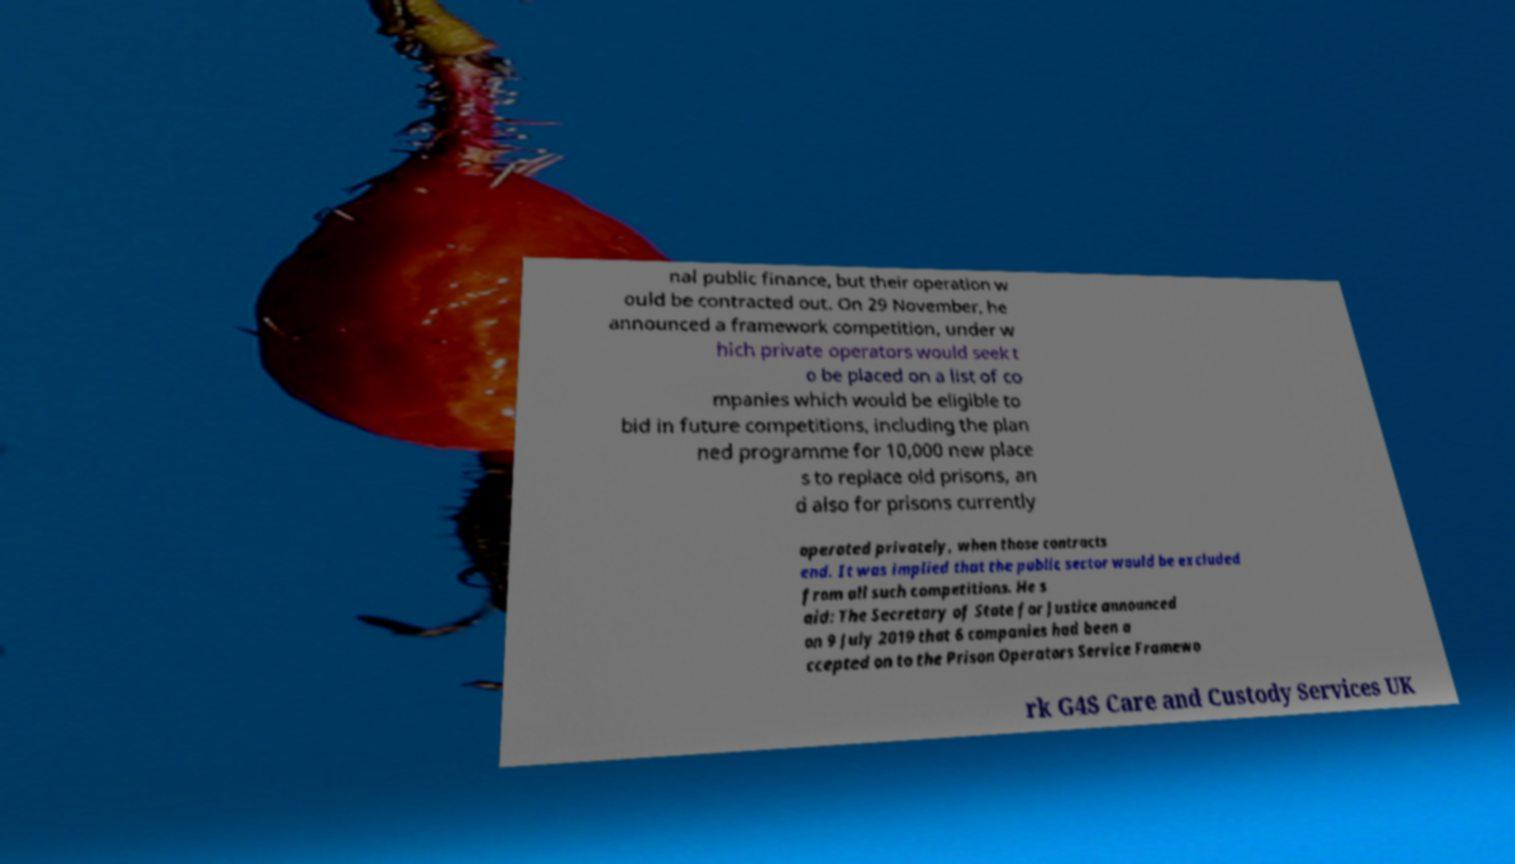Please identify and transcribe the text found in this image. nal public finance, but their operation w ould be contracted out. On 29 November, he announced a framework competition, under w hich private operators would seek t o be placed on a list of co mpanies which would be eligible to bid in future competitions, including the plan ned programme for 10,000 new place s to replace old prisons, an d also for prisons currently operated privately, when those contracts end. It was implied that the public sector would be excluded from all such competitions. He s aid: The Secretary of State for Justice announced on 9 July 2019 that 6 companies had been a ccepted on to the Prison Operators Service Framewo rk G4S Care and Custody Services UK 